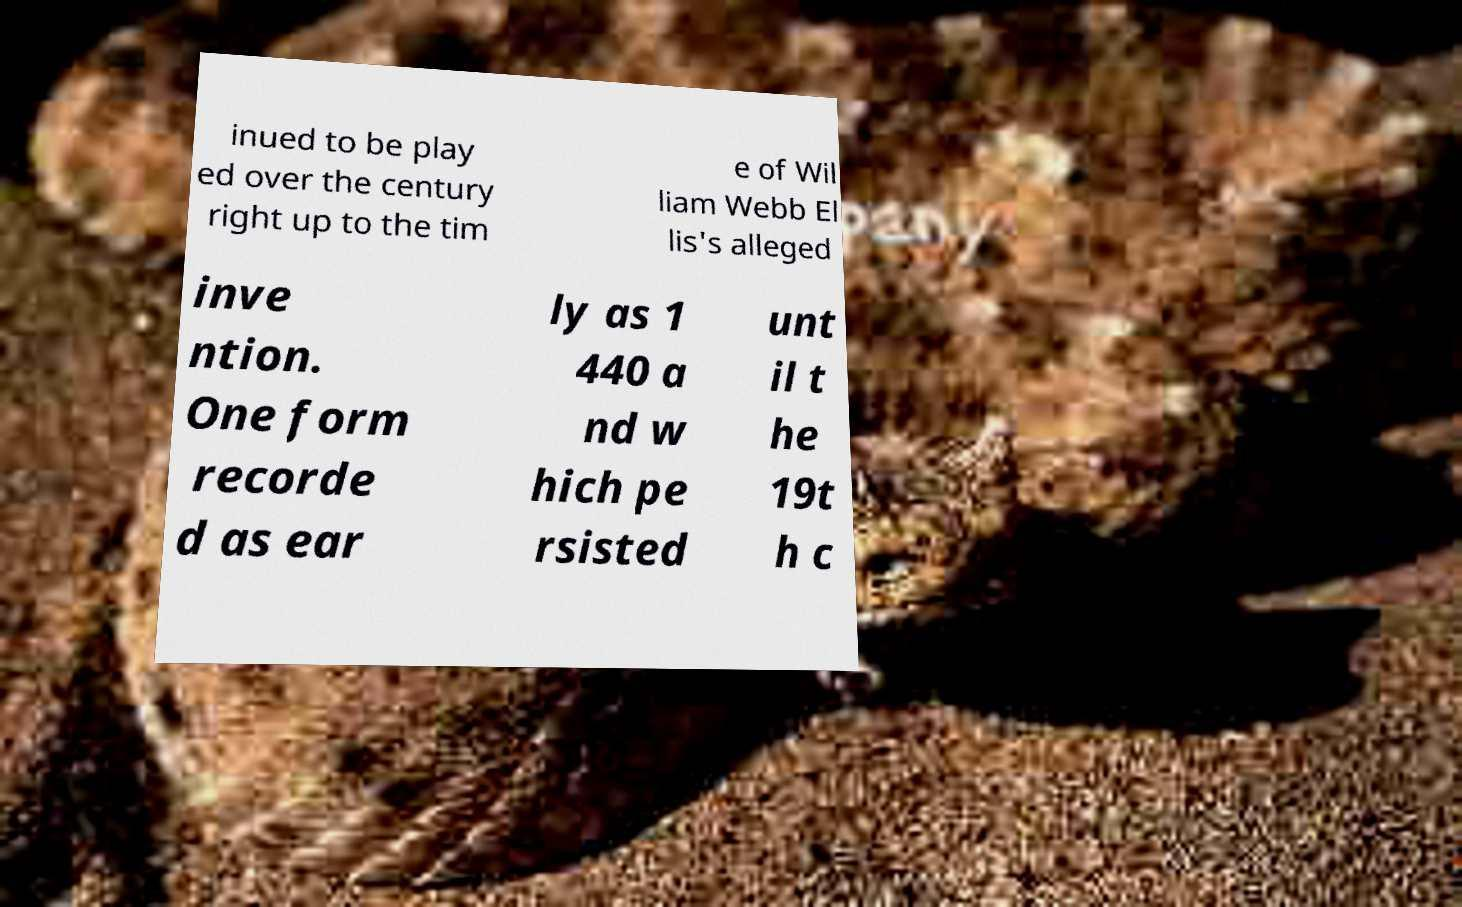Could you extract and type out the text from this image? inued to be play ed over the century right up to the tim e of Wil liam Webb El lis's alleged inve ntion. One form recorde d as ear ly as 1 440 a nd w hich pe rsisted unt il t he 19t h c 